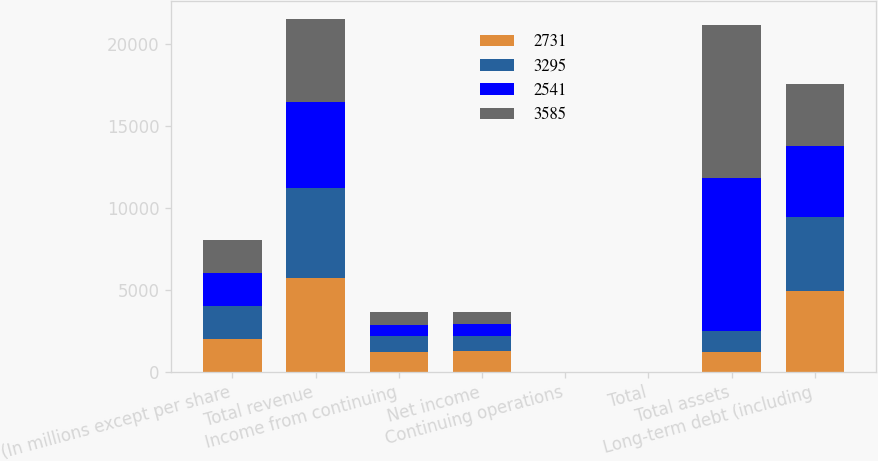Convert chart to OTSL. <chart><loc_0><loc_0><loc_500><loc_500><stacked_bar_chart><ecel><fcel>(In millions except per share<fcel>Total revenue<fcel>Income from continuing<fcel>Net income<fcel>Continuing operations<fcel>Total<fcel>Total assets<fcel>Long-term debt (including<nl><fcel>2731<fcel>2017<fcel>5696<fcel>1232<fcel>1246<fcel>5.84<fcel>5.9<fcel>1239<fcel>4900<nl><fcel>3295<fcel>2016<fcel>5505<fcel>930<fcel>930<fcel>4.22<fcel>4.22<fcel>1239<fcel>4562<nl><fcel>2541<fcel>2015<fcel>5254<fcel>712<fcel>712<fcel>3.04<fcel>3.04<fcel>9340<fcel>4293<nl><fcel>3585<fcel>2014<fcel>5066<fcel>754<fcel>754<fcel>3.04<fcel>3.03<fcel>9308<fcel>3790<nl></chart> 